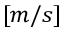<formula> <loc_0><loc_0><loc_500><loc_500>[ m / s ]</formula> 